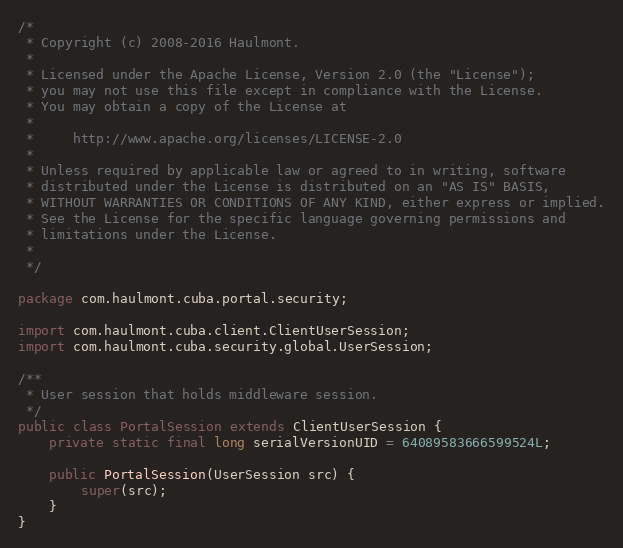<code> <loc_0><loc_0><loc_500><loc_500><_Java_>/*
 * Copyright (c) 2008-2016 Haulmont.
 *
 * Licensed under the Apache License, Version 2.0 (the "License");
 * you may not use this file except in compliance with the License.
 * You may obtain a copy of the License at
 *
 *     http://www.apache.org/licenses/LICENSE-2.0
 *
 * Unless required by applicable law or agreed to in writing, software
 * distributed under the License is distributed on an "AS IS" BASIS,
 * WITHOUT WARRANTIES OR CONDITIONS OF ANY KIND, either express or implied.
 * See the License for the specific language governing permissions and
 * limitations under the License.
 *
 */

package com.haulmont.cuba.portal.security;

import com.haulmont.cuba.client.ClientUserSession;
import com.haulmont.cuba.security.global.UserSession;

/**
 * User session that holds middleware session.
 */
public class PortalSession extends ClientUserSession {
    private static final long serialVersionUID = 64089583666599524L;

    public PortalSession(UserSession src) {
        super(src);
    }
}</code> 